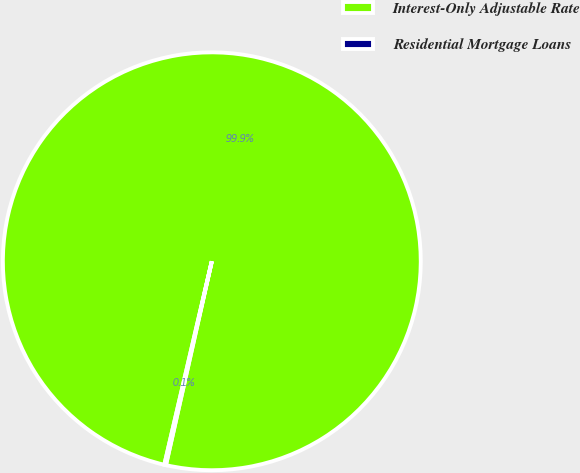<chart> <loc_0><loc_0><loc_500><loc_500><pie_chart><fcel>Interest-Only Adjustable Rate<fcel>Residential Mortgage Loans<nl><fcel>99.87%<fcel>0.13%<nl></chart> 